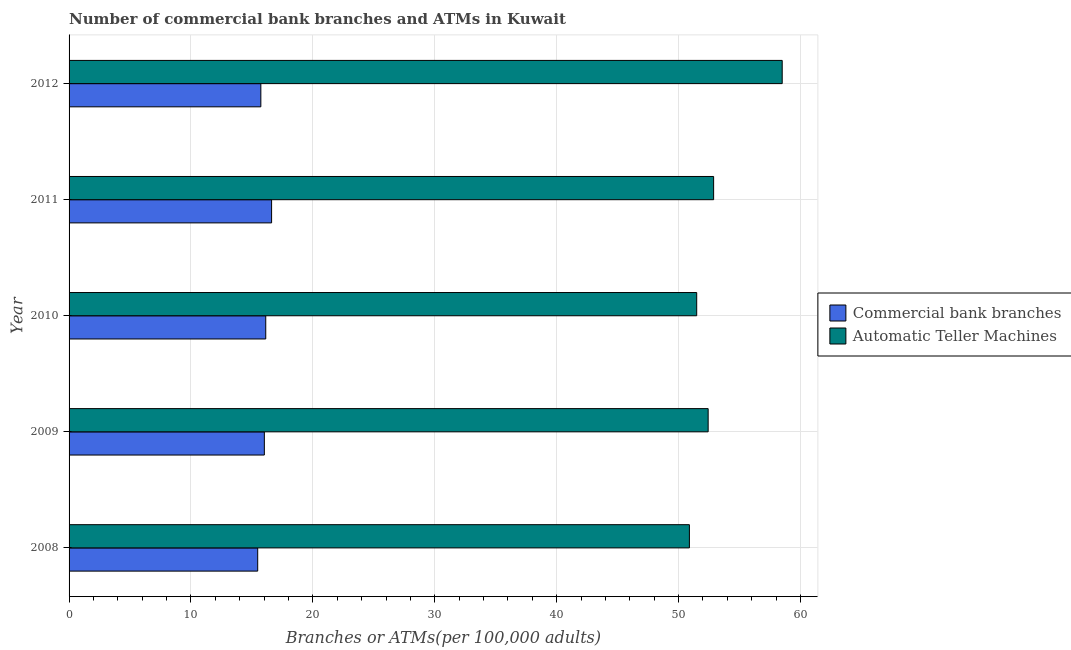How many different coloured bars are there?
Make the answer very short. 2. Are the number of bars per tick equal to the number of legend labels?
Give a very brief answer. Yes. How many bars are there on the 1st tick from the top?
Provide a succinct answer. 2. How many bars are there on the 3rd tick from the bottom?
Keep it short and to the point. 2. What is the label of the 1st group of bars from the top?
Your response must be concise. 2012. In how many cases, is the number of bars for a given year not equal to the number of legend labels?
Your answer should be compact. 0. What is the number of atms in 2010?
Ensure brevity in your answer.  51.49. Across all years, what is the maximum number of atms?
Give a very brief answer. 58.5. Across all years, what is the minimum number of atms?
Provide a short and direct response. 50.89. What is the total number of commercal bank branches in the graph?
Offer a very short reply. 79.97. What is the difference between the number of commercal bank branches in 2010 and the number of atms in 2012?
Offer a terse response. -42.37. What is the average number of atms per year?
Offer a very short reply. 53.23. In the year 2009, what is the difference between the number of commercal bank branches and number of atms?
Provide a short and direct response. -36.41. In how many years, is the number of commercal bank branches greater than 6 ?
Offer a terse response. 5. What is the difference between the highest and the second highest number of atms?
Keep it short and to the point. 5.63. What is the difference between the highest and the lowest number of commercal bank branches?
Make the answer very short. 1.14. What does the 1st bar from the top in 2010 represents?
Provide a succinct answer. Automatic Teller Machines. What does the 2nd bar from the bottom in 2008 represents?
Provide a succinct answer. Automatic Teller Machines. Are all the bars in the graph horizontal?
Your answer should be very brief. Yes. How many years are there in the graph?
Give a very brief answer. 5. What is the difference between two consecutive major ticks on the X-axis?
Your answer should be compact. 10. Are the values on the major ticks of X-axis written in scientific E-notation?
Make the answer very short. No. Does the graph contain grids?
Make the answer very short. Yes. Where does the legend appear in the graph?
Provide a short and direct response. Center right. What is the title of the graph?
Provide a succinct answer. Number of commercial bank branches and ATMs in Kuwait. Does "Goods" appear as one of the legend labels in the graph?
Offer a very short reply. No. What is the label or title of the X-axis?
Offer a terse response. Branches or ATMs(per 100,0 adults). What is the label or title of the Y-axis?
Give a very brief answer. Year. What is the Branches or ATMs(per 100,000 adults) in Commercial bank branches in 2008?
Make the answer very short. 15.47. What is the Branches or ATMs(per 100,000 adults) of Automatic Teller Machines in 2008?
Provide a succinct answer. 50.89. What is the Branches or ATMs(per 100,000 adults) of Commercial bank branches in 2009?
Your response must be concise. 16.02. What is the Branches or ATMs(per 100,000 adults) of Automatic Teller Machines in 2009?
Give a very brief answer. 52.43. What is the Branches or ATMs(per 100,000 adults) of Commercial bank branches in 2010?
Provide a short and direct response. 16.13. What is the Branches or ATMs(per 100,000 adults) in Automatic Teller Machines in 2010?
Offer a very short reply. 51.49. What is the Branches or ATMs(per 100,000 adults) in Commercial bank branches in 2011?
Give a very brief answer. 16.61. What is the Branches or ATMs(per 100,000 adults) in Automatic Teller Machines in 2011?
Your answer should be compact. 52.87. What is the Branches or ATMs(per 100,000 adults) of Commercial bank branches in 2012?
Your answer should be very brief. 15.73. What is the Branches or ATMs(per 100,000 adults) in Automatic Teller Machines in 2012?
Offer a terse response. 58.5. Across all years, what is the maximum Branches or ATMs(per 100,000 adults) of Commercial bank branches?
Your answer should be very brief. 16.61. Across all years, what is the maximum Branches or ATMs(per 100,000 adults) of Automatic Teller Machines?
Offer a very short reply. 58.5. Across all years, what is the minimum Branches or ATMs(per 100,000 adults) of Commercial bank branches?
Ensure brevity in your answer.  15.47. Across all years, what is the minimum Branches or ATMs(per 100,000 adults) of Automatic Teller Machines?
Offer a very short reply. 50.89. What is the total Branches or ATMs(per 100,000 adults) of Commercial bank branches in the graph?
Offer a terse response. 79.97. What is the total Branches or ATMs(per 100,000 adults) in Automatic Teller Machines in the graph?
Your response must be concise. 266.18. What is the difference between the Branches or ATMs(per 100,000 adults) in Commercial bank branches in 2008 and that in 2009?
Provide a succinct answer. -0.54. What is the difference between the Branches or ATMs(per 100,000 adults) in Automatic Teller Machines in 2008 and that in 2009?
Keep it short and to the point. -1.54. What is the difference between the Branches or ATMs(per 100,000 adults) of Commercial bank branches in 2008 and that in 2010?
Your response must be concise. -0.66. What is the difference between the Branches or ATMs(per 100,000 adults) in Automatic Teller Machines in 2008 and that in 2010?
Ensure brevity in your answer.  -0.6. What is the difference between the Branches or ATMs(per 100,000 adults) of Commercial bank branches in 2008 and that in 2011?
Your answer should be compact. -1.14. What is the difference between the Branches or ATMs(per 100,000 adults) in Automatic Teller Machines in 2008 and that in 2011?
Keep it short and to the point. -1.99. What is the difference between the Branches or ATMs(per 100,000 adults) of Commercial bank branches in 2008 and that in 2012?
Offer a very short reply. -0.26. What is the difference between the Branches or ATMs(per 100,000 adults) of Automatic Teller Machines in 2008 and that in 2012?
Your answer should be very brief. -7.61. What is the difference between the Branches or ATMs(per 100,000 adults) of Commercial bank branches in 2009 and that in 2010?
Your answer should be compact. -0.12. What is the difference between the Branches or ATMs(per 100,000 adults) of Automatic Teller Machines in 2009 and that in 2010?
Give a very brief answer. 0.94. What is the difference between the Branches or ATMs(per 100,000 adults) in Commercial bank branches in 2009 and that in 2011?
Provide a short and direct response. -0.6. What is the difference between the Branches or ATMs(per 100,000 adults) of Automatic Teller Machines in 2009 and that in 2011?
Offer a terse response. -0.45. What is the difference between the Branches or ATMs(per 100,000 adults) in Commercial bank branches in 2009 and that in 2012?
Give a very brief answer. 0.29. What is the difference between the Branches or ATMs(per 100,000 adults) in Automatic Teller Machines in 2009 and that in 2012?
Your answer should be very brief. -6.07. What is the difference between the Branches or ATMs(per 100,000 adults) of Commercial bank branches in 2010 and that in 2011?
Offer a very short reply. -0.48. What is the difference between the Branches or ATMs(per 100,000 adults) in Automatic Teller Machines in 2010 and that in 2011?
Your response must be concise. -1.39. What is the difference between the Branches or ATMs(per 100,000 adults) in Commercial bank branches in 2010 and that in 2012?
Offer a terse response. 0.4. What is the difference between the Branches or ATMs(per 100,000 adults) of Automatic Teller Machines in 2010 and that in 2012?
Provide a short and direct response. -7.01. What is the difference between the Branches or ATMs(per 100,000 adults) of Commercial bank branches in 2011 and that in 2012?
Provide a short and direct response. 0.88. What is the difference between the Branches or ATMs(per 100,000 adults) in Automatic Teller Machines in 2011 and that in 2012?
Ensure brevity in your answer.  -5.63. What is the difference between the Branches or ATMs(per 100,000 adults) in Commercial bank branches in 2008 and the Branches or ATMs(per 100,000 adults) in Automatic Teller Machines in 2009?
Ensure brevity in your answer.  -36.95. What is the difference between the Branches or ATMs(per 100,000 adults) of Commercial bank branches in 2008 and the Branches or ATMs(per 100,000 adults) of Automatic Teller Machines in 2010?
Provide a short and direct response. -36.01. What is the difference between the Branches or ATMs(per 100,000 adults) in Commercial bank branches in 2008 and the Branches or ATMs(per 100,000 adults) in Automatic Teller Machines in 2011?
Your response must be concise. -37.4. What is the difference between the Branches or ATMs(per 100,000 adults) of Commercial bank branches in 2008 and the Branches or ATMs(per 100,000 adults) of Automatic Teller Machines in 2012?
Provide a succinct answer. -43.03. What is the difference between the Branches or ATMs(per 100,000 adults) of Commercial bank branches in 2009 and the Branches or ATMs(per 100,000 adults) of Automatic Teller Machines in 2010?
Your response must be concise. -35.47. What is the difference between the Branches or ATMs(per 100,000 adults) in Commercial bank branches in 2009 and the Branches or ATMs(per 100,000 adults) in Automatic Teller Machines in 2011?
Offer a very short reply. -36.86. What is the difference between the Branches or ATMs(per 100,000 adults) of Commercial bank branches in 2009 and the Branches or ATMs(per 100,000 adults) of Automatic Teller Machines in 2012?
Offer a very short reply. -42.48. What is the difference between the Branches or ATMs(per 100,000 adults) of Commercial bank branches in 2010 and the Branches or ATMs(per 100,000 adults) of Automatic Teller Machines in 2011?
Offer a terse response. -36.74. What is the difference between the Branches or ATMs(per 100,000 adults) in Commercial bank branches in 2010 and the Branches or ATMs(per 100,000 adults) in Automatic Teller Machines in 2012?
Your response must be concise. -42.37. What is the difference between the Branches or ATMs(per 100,000 adults) in Commercial bank branches in 2011 and the Branches or ATMs(per 100,000 adults) in Automatic Teller Machines in 2012?
Make the answer very short. -41.89. What is the average Branches or ATMs(per 100,000 adults) of Commercial bank branches per year?
Provide a succinct answer. 15.99. What is the average Branches or ATMs(per 100,000 adults) of Automatic Teller Machines per year?
Keep it short and to the point. 53.24. In the year 2008, what is the difference between the Branches or ATMs(per 100,000 adults) of Commercial bank branches and Branches or ATMs(per 100,000 adults) of Automatic Teller Machines?
Give a very brief answer. -35.41. In the year 2009, what is the difference between the Branches or ATMs(per 100,000 adults) of Commercial bank branches and Branches or ATMs(per 100,000 adults) of Automatic Teller Machines?
Offer a terse response. -36.41. In the year 2010, what is the difference between the Branches or ATMs(per 100,000 adults) of Commercial bank branches and Branches or ATMs(per 100,000 adults) of Automatic Teller Machines?
Keep it short and to the point. -35.35. In the year 2011, what is the difference between the Branches or ATMs(per 100,000 adults) in Commercial bank branches and Branches or ATMs(per 100,000 adults) in Automatic Teller Machines?
Give a very brief answer. -36.26. In the year 2012, what is the difference between the Branches or ATMs(per 100,000 adults) of Commercial bank branches and Branches or ATMs(per 100,000 adults) of Automatic Teller Machines?
Offer a very short reply. -42.77. What is the ratio of the Branches or ATMs(per 100,000 adults) in Automatic Teller Machines in 2008 to that in 2009?
Ensure brevity in your answer.  0.97. What is the ratio of the Branches or ATMs(per 100,000 adults) of Commercial bank branches in 2008 to that in 2010?
Give a very brief answer. 0.96. What is the ratio of the Branches or ATMs(per 100,000 adults) in Automatic Teller Machines in 2008 to that in 2010?
Ensure brevity in your answer.  0.99. What is the ratio of the Branches or ATMs(per 100,000 adults) of Commercial bank branches in 2008 to that in 2011?
Make the answer very short. 0.93. What is the ratio of the Branches or ATMs(per 100,000 adults) of Automatic Teller Machines in 2008 to that in 2011?
Keep it short and to the point. 0.96. What is the ratio of the Branches or ATMs(per 100,000 adults) of Commercial bank branches in 2008 to that in 2012?
Your answer should be very brief. 0.98. What is the ratio of the Branches or ATMs(per 100,000 adults) of Automatic Teller Machines in 2008 to that in 2012?
Ensure brevity in your answer.  0.87. What is the ratio of the Branches or ATMs(per 100,000 adults) in Commercial bank branches in 2009 to that in 2010?
Ensure brevity in your answer.  0.99. What is the ratio of the Branches or ATMs(per 100,000 adults) in Automatic Teller Machines in 2009 to that in 2010?
Offer a terse response. 1.02. What is the ratio of the Branches or ATMs(per 100,000 adults) of Commercial bank branches in 2009 to that in 2011?
Your answer should be compact. 0.96. What is the ratio of the Branches or ATMs(per 100,000 adults) in Automatic Teller Machines in 2009 to that in 2011?
Provide a succinct answer. 0.99. What is the ratio of the Branches or ATMs(per 100,000 adults) in Commercial bank branches in 2009 to that in 2012?
Keep it short and to the point. 1.02. What is the ratio of the Branches or ATMs(per 100,000 adults) in Automatic Teller Machines in 2009 to that in 2012?
Offer a very short reply. 0.9. What is the ratio of the Branches or ATMs(per 100,000 adults) in Commercial bank branches in 2010 to that in 2011?
Keep it short and to the point. 0.97. What is the ratio of the Branches or ATMs(per 100,000 adults) of Automatic Teller Machines in 2010 to that in 2011?
Offer a very short reply. 0.97. What is the ratio of the Branches or ATMs(per 100,000 adults) of Commercial bank branches in 2010 to that in 2012?
Make the answer very short. 1.03. What is the ratio of the Branches or ATMs(per 100,000 adults) in Automatic Teller Machines in 2010 to that in 2012?
Your answer should be compact. 0.88. What is the ratio of the Branches or ATMs(per 100,000 adults) of Commercial bank branches in 2011 to that in 2012?
Provide a short and direct response. 1.06. What is the ratio of the Branches or ATMs(per 100,000 adults) of Automatic Teller Machines in 2011 to that in 2012?
Make the answer very short. 0.9. What is the difference between the highest and the second highest Branches or ATMs(per 100,000 adults) of Commercial bank branches?
Your answer should be compact. 0.48. What is the difference between the highest and the second highest Branches or ATMs(per 100,000 adults) of Automatic Teller Machines?
Your answer should be very brief. 5.63. What is the difference between the highest and the lowest Branches or ATMs(per 100,000 adults) of Commercial bank branches?
Offer a very short reply. 1.14. What is the difference between the highest and the lowest Branches or ATMs(per 100,000 adults) of Automatic Teller Machines?
Make the answer very short. 7.61. 